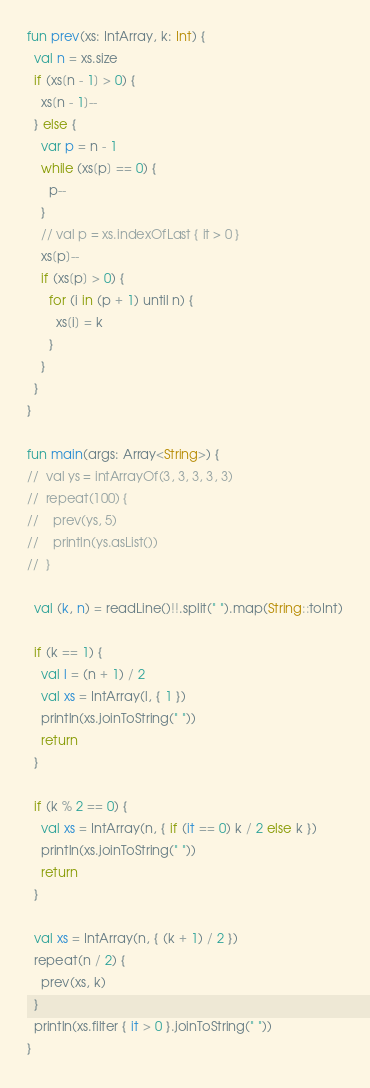<code> <loc_0><loc_0><loc_500><loc_500><_Kotlin_>fun prev(xs: IntArray, k: Int) {
  val n = xs.size
  if (xs[n - 1] > 0) {
    xs[n - 1]--
  } else {
    var p = n - 1
    while (xs[p] == 0) {
      p--
    }
    // val p = xs.indexOfLast { it > 0 }
    xs[p]--
    if (xs[p] > 0) {
      for (i in (p + 1) until n) {
        xs[i] = k
      }
    }
  }
}

fun main(args: Array<String>) {
//  val ys = intArrayOf(3, 3, 3, 3, 3)
//  repeat(100) {
//    prev(ys, 5)
//    println(ys.asList())
//  }

  val (k, n) = readLine()!!.split(" ").map(String::toInt)

  if (k == 1) {
    val l = (n + 1) / 2
    val xs = IntArray(l, { 1 })
    println(xs.joinToString(" "))
    return
  }

  if (k % 2 == 0) {
    val xs = IntArray(n, { if (it == 0) k / 2 else k })
    println(xs.joinToString(" "))
    return
  }

  val xs = IntArray(n, { (k + 1) / 2 })
  repeat(n / 2) {
    prev(xs, k)
  }
  println(xs.filter { it > 0 }.joinToString(" "))
}
</code> 